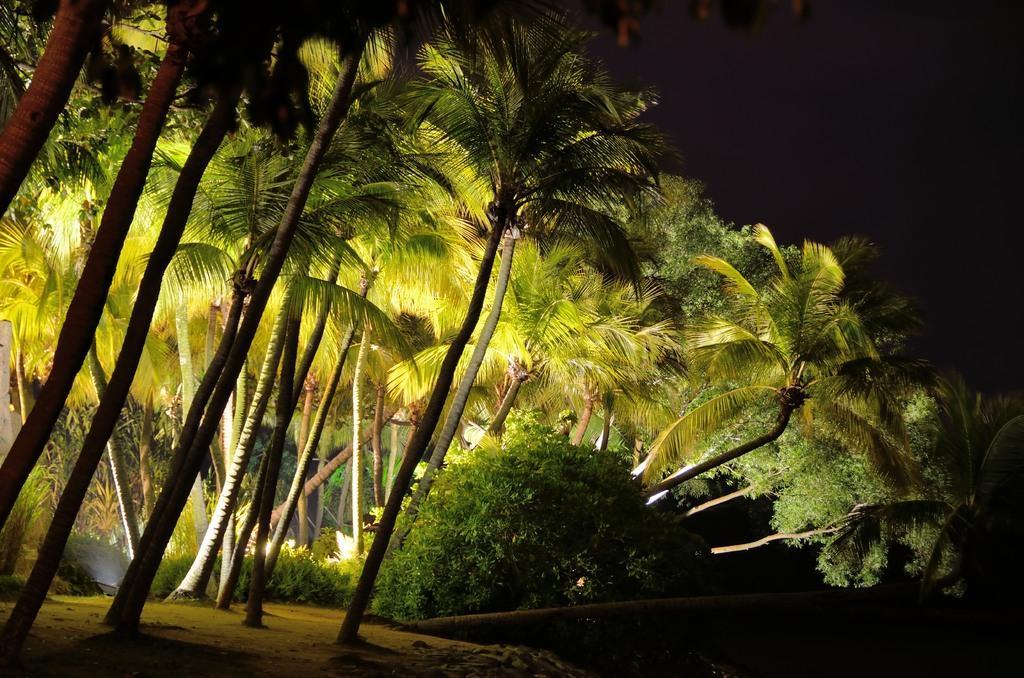Can you describe this image briefly? In the background of the image we can see the trees. At the bottom of the image we can see the ground. At the top of the image we can see the sky. 